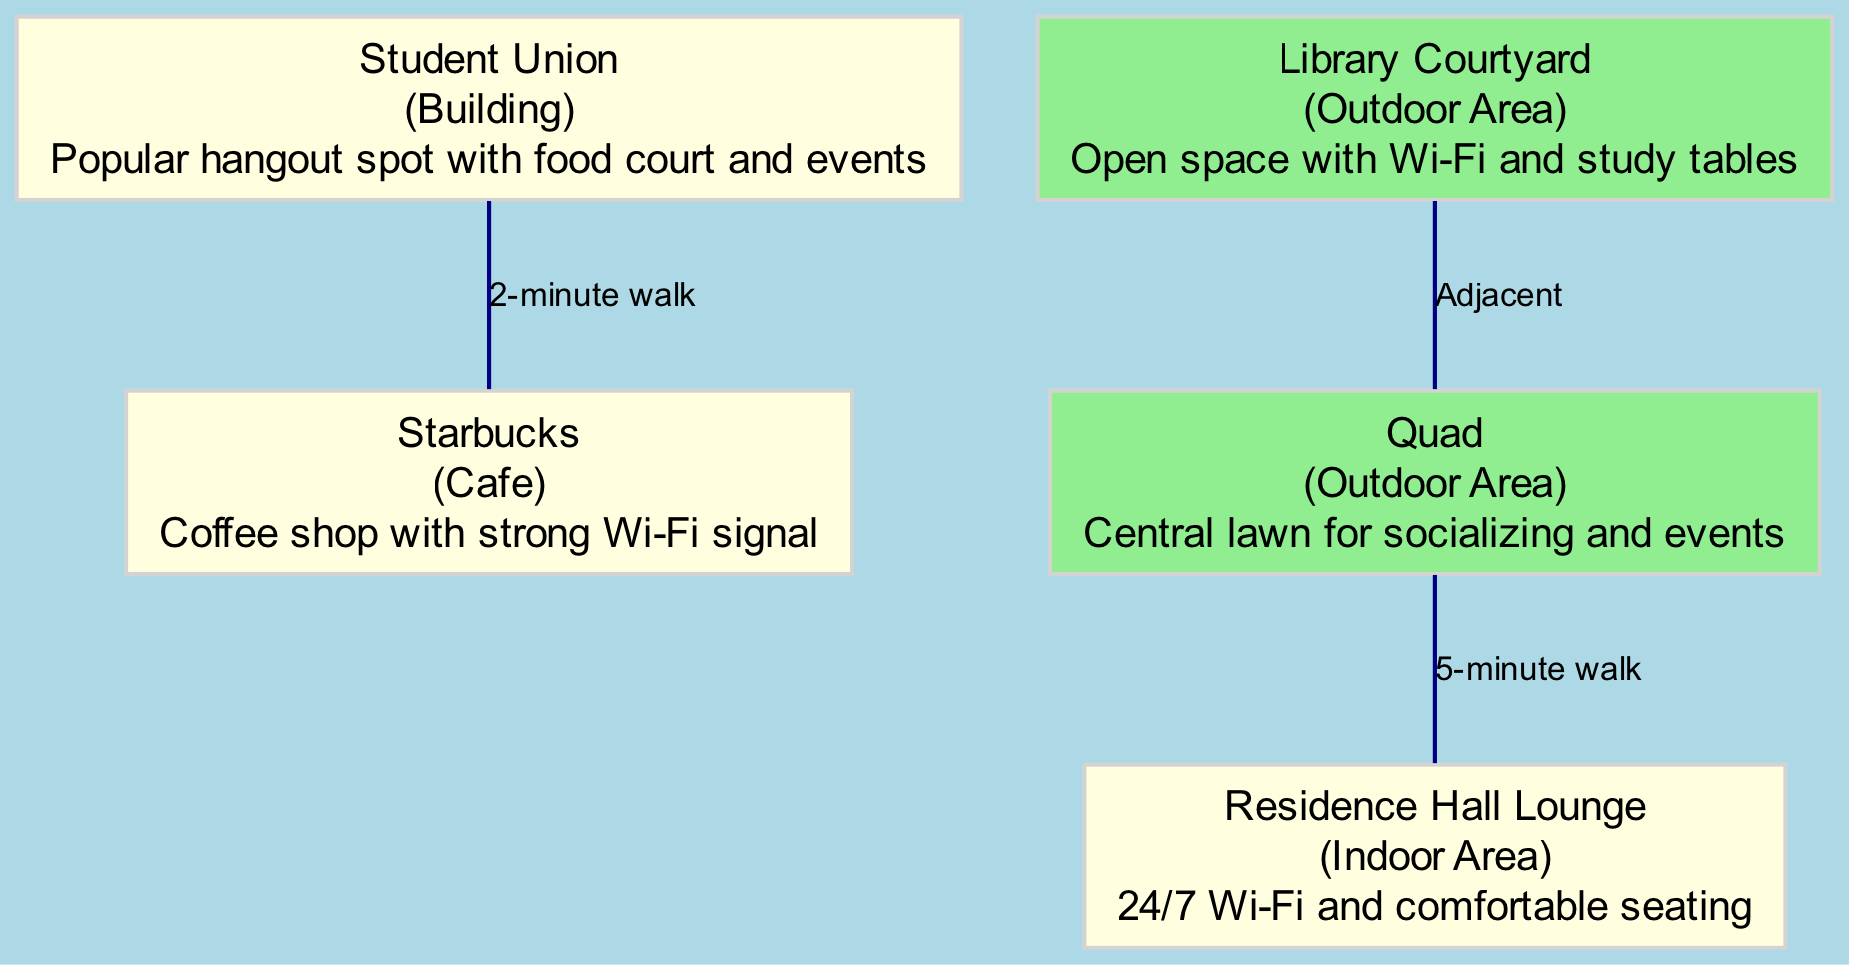What is the name of the central lawn for socializing? The diagram shows the node labeled "Quad", which is specifically described as the central lawn for socializing and events.
Answer: Quad Which building has a food court and hosts events? According to the diagram, the "Student Union" is identified as a popular hangout spot that includes a food court and hosts events.
Answer: Student Union How many outdoor areas are highlighted on the map? The diagram features two nodes categorized as outdoor areas: "Library Courtyard" and "Quad". By counting these nodes, we determine that there are two outdoor areas.
Answer: 2 What type of establishment is Starbucks? The diagram describes "Starbucks" as a cafe where students can enjoy coffee and experience a strong Wi-Fi signal.
Answer: Cafe What is the distance from the Student Union to Starbucks? The edge between nodes "1" (Student Union) and "3" (Starbucks) notes that it is a 2-minute walk, indicating the distance in time between the two locations.
Answer: 2-minute walk What connects the Library Courtyard and the Quad? The diagram specifies that the Library Courtyard is adjacent to the Quad, indicating a direct connection without any distance measurement needed.
Answer: Adjacent Where can students find 24/7 Wi-Fi with comfortable seating? The "Residence Hall Lounge" is noted in the diagram as a location with 24/7 Wi-Fi and comfortable seating, making it a suitable spot for students looking for a place to relax.
Answer: Residence Hall Lounge What is the walking time from the Quad to the Residence Hall Lounge? The edge connecting nodes "4" (Quad) and "5" (Residence Hall Lounge) in the diagram states that it is a 5-minute walk, which indicates the distance in time to travel between these two areas.
Answer: 5-minute walk Which location in the diagram provides an open space for studying with Wi-Fi? The "Library Courtyard" is specifically identified in the diagram as an open space that offers Wi-Fi along with study tables, making it a conducive area for studying.
Answer: Library Courtyard 